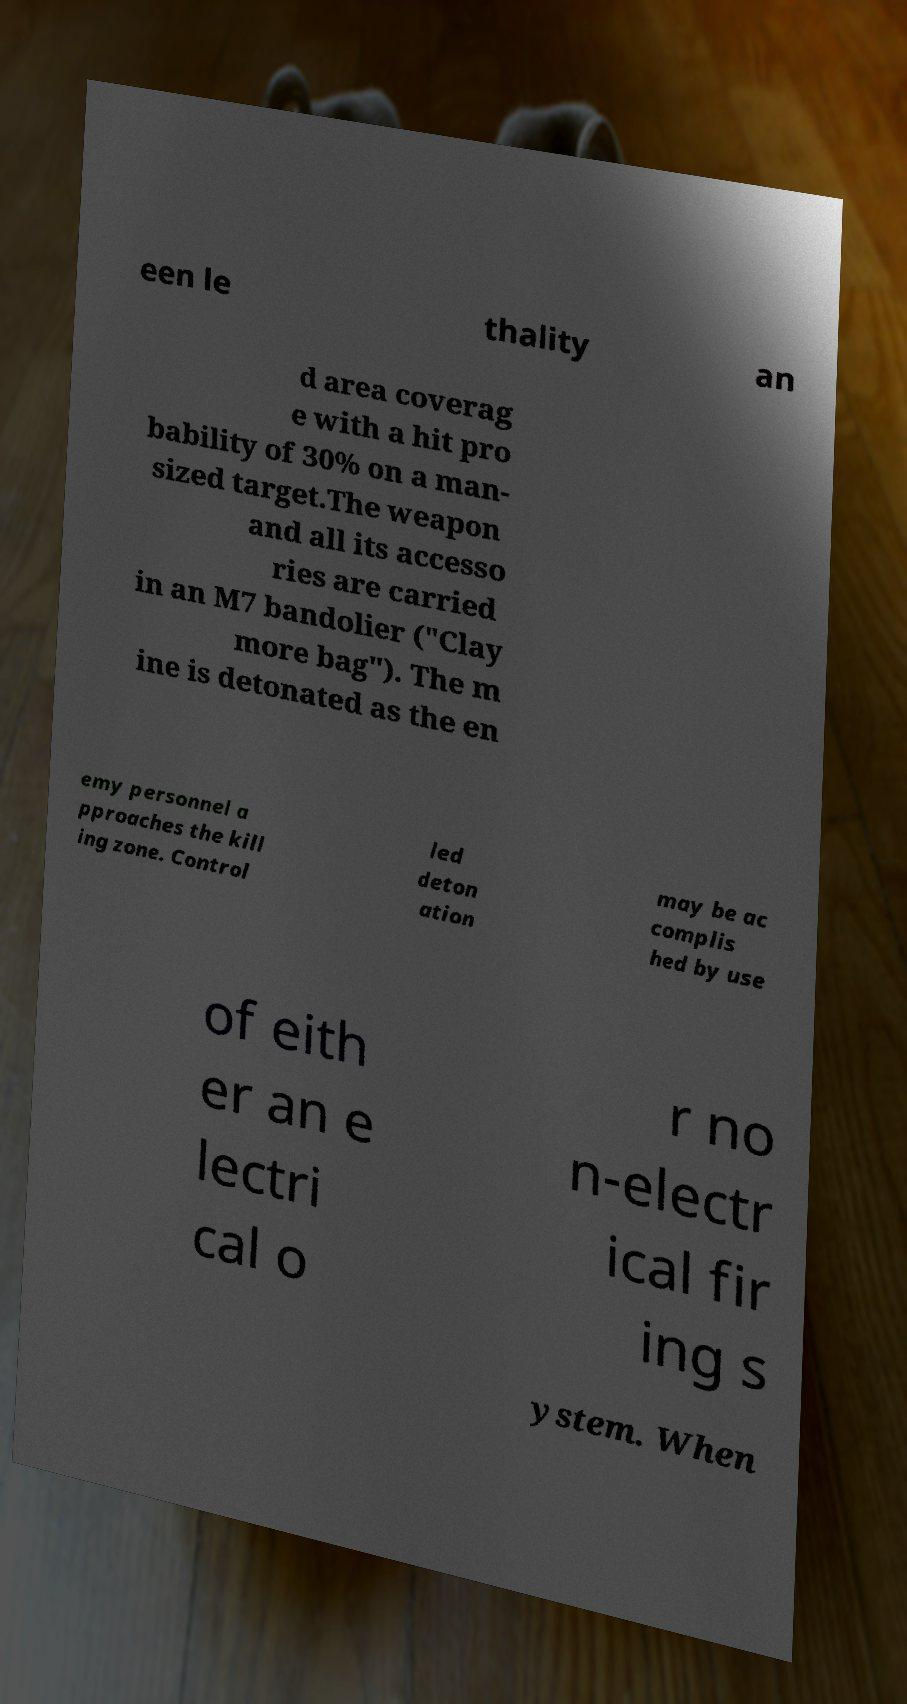Please read and relay the text visible in this image. What does it say? een le thality an d area coverag e with a hit pro bability of 30% on a man- sized target.The weapon and all its accesso ries are carried in an M7 bandolier ("Clay more bag"). The m ine is detonated as the en emy personnel a pproaches the kill ing zone. Control led deton ation may be ac complis hed by use of eith er an e lectri cal o r no n-electr ical fir ing s ystem. When 